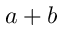<formula> <loc_0><loc_0><loc_500><loc_500>a + b</formula> 